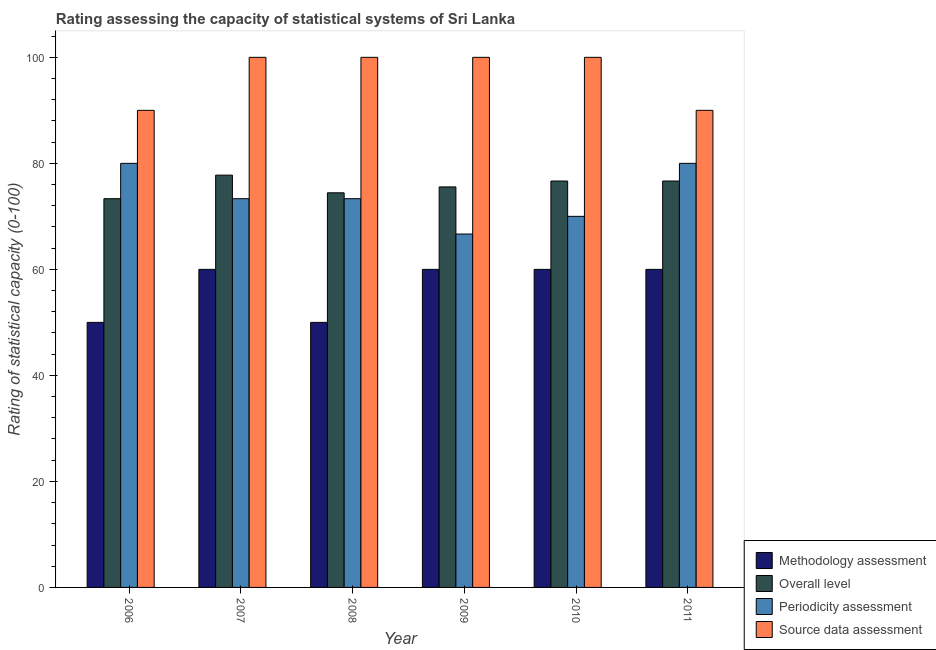How many different coloured bars are there?
Give a very brief answer. 4. Are the number of bars on each tick of the X-axis equal?
Provide a short and direct response. Yes. How many bars are there on the 3rd tick from the left?
Keep it short and to the point. 4. How many bars are there on the 5th tick from the right?
Your response must be concise. 4. What is the label of the 2nd group of bars from the left?
Make the answer very short. 2007. What is the methodology assessment rating in 2010?
Your answer should be compact. 60. Across all years, what is the maximum source data assessment rating?
Provide a succinct answer. 100. Across all years, what is the minimum source data assessment rating?
Give a very brief answer. 90. In which year was the methodology assessment rating minimum?
Your answer should be very brief. 2006. What is the total source data assessment rating in the graph?
Provide a succinct answer. 580. What is the difference between the overall level rating in 2008 and that in 2009?
Provide a short and direct response. -1.11. What is the difference between the methodology assessment rating in 2008 and the overall level rating in 2009?
Offer a very short reply. -10. What is the average methodology assessment rating per year?
Provide a succinct answer. 56.67. In the year 2010, what is the difference between the source data assessment rating and methodology assessment rating?
Give a very brief answer. 0. What is the ratio of the methodology assessment rating in 2006 to that in 2007?
Offer a very short reply. 0.83. What is the difference between the highest and the second highest source data assessment rating?
Give a very brief answer. 0. What is the difference between the highest and the lowest source data assessment rating?
Your answer should be compact. 10. Is the sum of the overall level rating in 2009 and 2010 greater than the maximum source data assessment rating across all years?
Give a very brief answer. Yes. Is it the case that in every year, the sum of the source data assessment rating and methodology assessment rating is greater than the sum of periodicity assessment rating and overall level rating?
Offer a terse response. Yes. What does the 4th bar from the left in 2006 represents?
Keep it short and to the point. Source data assessment. What does the 1st bar from the right in 2006 represents?
Your answer should be very brief. Source data assessment. How many bars are there?
Ensure brevity in your answer.  24. Are the values on the major ticks of Y-axis written in scientific E-notation?
Your response must be concise. No. Does the graph contain any zero values?
Provide a succinct answer. No. Does the graph contain grids?
Your answer should be compact. No. How many legend labels are there?
Your answer should be compact. 4. How are the legend labels stacked?
Your answer should be very brief. Vertical. What is the title of the graph?
Make the answer very short. Rating assessing the capacity of statistical systems of Sri Lanka. Does "Fiscal policy" appear as one of the legend labels in the graph?
Your answer should be compact. No. What is the label or title of the X-axis?
Make the answer very short. Year. What is the label or title of the Y-axis?
Provide a short and direct response. Rating of statistical capacity (0-100). What is the Rating of statistical capacity (0-100) in Methodology assessment in 2006?
Offer a terse response. 50. What is the Rating of statistical capacity (0-100) in Overall level in 2006?
Offer a very short reply. 73.33. What is the Rating of statistical capacity (0-100) in Periodicity assessment in 2006?
Make the answer very short. 80. What is the Rating of statistical capacity (0-100) of Methodology assessment in 2007?
Your answer should be very brief. 60. What is the Rating of statistical capacity (0-100) of Overall level in 2007?
Provide a short and direct response. 77.78. What is the Rating of statistical capacity (0-100) of Periodicity assessment in 2007?
Make the answer very short. 73.33. What is the Rating of statistical capacity (0-100) in Overall level in 2008?
Provide a short and direct response. 74.44. What is the Rating of statistical capacity (0-100) in Periodicity assessment in 2008?
Keep it short and to the point. 73.33. What is the Rating of statistical capacity (0-100) of Source data assessment in 2008?
Keep it short and to the point. 100. What is the Rating of statistical capacity (0-100) in Methodology assessment in 2009?
Ensure brevity in your answer.  60. What is the Rating of statistical capacity (0-100) of Overall level in 2009?
Provide a succinct answer. 75.56. What is the Rating of statistical capacity (0-100) in Periodicity assessment in 2009?
Make the answer very short. 66.67. What is the Rating of statistical capacity (0-100) of Overall level in 2010?
Your answer should be compact. 76.67. What is the Rating of statistical capacity (0-100) in Periodicity assessment in 2010?
Keep it short and to the point. 70. What is the Rating of statistical capacity (0-100) in Source data assessment in 2010?
Provide a succinct answer. 100. What is the Rating of statistical capacity (0-100) of Overall level in 2011?
Provide a succinct answer. 76.67. What is the Rating of statistical capacity (0-100) of Periodicity assessment in 2011?
Your response must be concise. 80. Across all years, what is the maximum Rating of statistical capacity (0-100) of Methodology assessment?
Ensure brevity in your answer.  60. Across all years, what is the maximum Rating of statistical capacity (0-100) in Overall level?
Keep it short and to the point. 77.78. Across all years, what is the maximum Rating of statistical capacity (0-100) of Periodicity assessment?
Give a very brief answer. 80. Across all years, what is the minimum Rating of statistical capacity (0-100) in Methodology assessment?
Provide a short and direct response. 50. Across all years, what is the minimum Rating of statistical capacity (0-100) of Overall level?
Provide a succinct answer. 73.33. Across all years, what is the minimum Rating of statistical capacity (0-100) in Periodicity assessment?
Provide a short and direct response. 66.67. Across all years, what is the minimum Rating of statistical capacity (0-100) in Source data assessment?
Your answer should be very brief. 90. What is the total Rating of statistical capacity (0-100) of Methodology assessment in the graph?
Offer a very short reply. 340. What is the total Rating of statistical capacity (0-100) of Overall level in the graph?
Your response must be concise. 454.44. What is the total Rating of statistical capacity (0-100) in Periodicity assessment in the graph?
Your response must be concise. 443.33. What is the total Rating of statistical capacity (0-100) in Source data assessment in the graph?
Your response must be concise. 580. What is the difference between the Rating of statistical capacity (0-100) in Methodology assessment in 2006 and that in 2007?
Give a very brief answer. -10. What is the difference between the Rating of statistical capacity (0-100) in Overall level in 2006 and that in 2007?
Keep it short and to the point. -4.44. What is the difference between the Rating of statistical capacity (0-100) in Overall level in 2006 and that in 2008?
Offer a terse response. -1.11. What is the difference between the Rating of statistical capacity (0-100) of Periodicity assessment in 2006 and that in 2008?
Ensure brevity in your answer.  6.67. What is the difference between the Rating of statistical capacity (0-100) of Source data assessment in 2006 and that in 2008?
Your response must be concise. -10. What is the difference between the Rating of statistical capacity (0-100) in Methodology assessment in 2006 and that in 2009?
Keep it short and to the point. -10. What is the difference between the Rating of statistical capacity (0-100) of Overall level in 2006 and that in 2009?
Your answer should be very brief. -2.22. What is the difference between the Rating of statistical capacity (0-100) of Periodicity assessment in 2006 and that in 2009?
Ensure brevity in your answer.  13.33. What is the difference between the Rating of statistical capacity (0-100) in Source data assessment in 2006 and that in 2009?
Provide a succinct answer. -10. What is the difference between the Rating of statistical capacity (0-100) in Overall level in 2006 and that in 2010?
Provide a short and direct response. -3.33. What is the difference between the Rating of statistical capacity (0-100) of Source data assessment in 2006 and that in 2010?
Ensure brevity in your answer.  -10. What is the difference between the Rating of statistical capacity (0-100) in Methodology assessment in 2006 and that in 2011?
Give a very brief answer. -10. What is the difference between the Rating of statistical capacity (0-100) in Overall level in 2006 and that in 2011?
Give a very brief answer. -3.33. What is the difference between the Rating of statistical capacity (0-100) of Methodology assessment in 2007 and that in 2008?
Offer a terse response. 10. What is the difference between the Rating of statistical capacity (0-100) of Overall level in 2007 and that in 2008?
Your answer should be very brief. 3.33. What is the difference between the Rating of statistical capacity (0-100) of Periodicity assessment in 2007 and that in 2008?
Your response must be concise. 0. What is the difference between the Rating of statistical capacity (0-100) in Source data assessment in 2007 and that in 2008?
Provide a short and direct response. 0. What is the difference between the Rating of statistical capacity (0-100) in Methodology assessment in 2007 and that in 2009?
Offer a very short reply. 0. What is the difference between the Rating of statistical capacity (0-100) of Overall level in 2007 and that in 2009?
Ensure brevity in your answer.  2.22. What is the difference between the Rating of statistical capacity (0-100) in Periodicity assessment in 2007 and that in 2009?
Provide a succinct answer. 6.67. What is the difference between the Rating of statistical capacity (0-100) in Overall level in 2007 and that in 2010?
Ensure brevity in your answer.  1.11. What is the difference between the Rating of statistical capacity (0-100) of Methodology assessment in 2007 and that in 2011?
Your answer should be compact. 0. What is the difference between the Rating of statistical capacity (0-100) in Periodicity assessment in 2007 and that in 2011?
Offer a very short reply. -6.67. What is the difference between the Rating of statistical capacity (0-100) in Source data assessment in 2007 and that in 2011?
Give a very brief answer. 10. What is the difference between the Rating of statistical capacity (0-100) in Methodology assessment in 2008 and that in 2009?
Offer a terse response. -10. What is the difference between the Rating of statistical capacity (0-100) of Overall level in 2008 and that in 2009?
Give a very brief answer. -1.11. What is the difference between the Rating of statistical capacity (0-100) in Source data assessment in 2008 and that in 2009?
Give a very brief answer. 0. What is the difference between the Rating of statistical capacity (0-100) of Methodology assessment in 2008 and that in 2010?
Provide a succinct answer. -10. What is the difference between the Rating of statistical capacity (0-100) in Overall level in 2008 and that in 2010?
Provide a succinct answer. -2.22. What is the difference between the Rating of statistical capacity (0-100) in Periodicity assessment in 2008 and that in 2010?
Ensure brevity in your answer.  3.33. What is the difference between the Rating of statistical capacity (0-100) in Overall level in 2008 and that in 2011?
Offer a terse response. -2.22. What is the difference between the Rating of statistical capacity (0-100) of Periodicity assessment in 2008 and that in 2011?
Provide a succinct answer. -6.67. What is the difference between the Rating of statistical capacity (0-100) of Source data assessment in 2008 and that in 2011?
Provide a succinct answer. 10. What is the difference between the Rating of statistical capacity (0-100) in Overall level in 2009 and that in 2010?
Give a very brief answer. -1.11. What is the difference between the Rating of statistical capacity (0-100) in Periodicity assessment in 2009 and that in 2010?
Keep it short and to the point. -3.33. What is the difference between the Rating of statistical capacity (0-100) of Methodology assessment in 2009 and that in 2011?
Your answer should be compact. 0. What is the difference between the Rating of statistical capacity (0-100) of Overall level in 2009 and that in 2011?
Ensure brevity in your answer.  -1.11. What is the difference between the Rating of statistical capacity (0-100) of Periodicity assessment in 2009 and that in 2011?
Provide a succinct answer. -13.33. What is the difference between the Rating of statistical capacity (0-100) in Source data assessment in 2009 and that in 2011?
Provide a succinct answer. 10. What is the difference between the Rating of statistical capacity (0-100) in Methodology assessment in 2010 and that in 2011?
Offer a very short reply. 0. What is the difference between the Rating of statistical capacity (0-100) in Source data assessment in 2010 and that in 2011?
Your answer should be compact. 10. What is the difference between the Rating of statistical capacity (0-100) in Methodology assessment in 2006 and the Rating of statistical capacity (0-100) in Overall level in 2007?
Your answer should be compact. -27.78. What is the difference between the Rating of statistical capacity (0-100) of Methodology assessment in 2006 and the Rating of statistical capacity (0-100) of Periodicity assessment in 2007?
Offer a very short reply. -23.33. What is the difference between the Rating of statistical capacity (0-100) of Methodology assessment in 2006 and the Rating of statistical capacity (0-100) of Source data assessment in 2007?
Provide a succinct answer. -50. What is the difference between the Rating of statistical capacity (0-100) in Overall level in 2006 and the Rating of statistical capacity (0-100) in Source data assessment in 2007?
Offer a terse response. -26.67. What is the difference between the Rating of statistical capacity (0-100) in Methodology assessment in 2006 and the Rating of statistical capacity (0-100) in Overall level in 2008?
Your response must be concise. -24.44. What is the difference between the Rating of statistical capacity (0-100) in Methodology assessment in 2006 and the Rating of statistical capacity (0-100) in Periodicity assessment in 2008?
Provide a short and direct response. -23.33. What is the difference between the Rating of statistical capacity (0-100) of Methodology assessment in 2006 and the Rating of statistical capacity (0-100) of Source data assessment in 2008?
Make the answer very short. -50. What is the difference between the Rating of statistical capacity (0-100) of Overall level in 2006 and the Rating of statistical capacity (0-100) of Periodicity assessment in 2008?
Give a very brief answer. 0. What is the difference between the Rating of statistical capacity (0-100) in Overall level in 2006 and the Rating of statistical capacity (0-100) in Source data assessment in 2008?
Your answer should be compact. -26.67. What is the difference between the Rating of statistical capacity (0-100) in Periodicity assessment in 2006 and the Rating of statistical capacity (0-100) in Source data assessment in 2008?
Give a very brief answer. -20. What is the difference between the Rating of statistical capacity (0-100) of Methodology assessment in 2006 and the Rating of statistical capacity (0-100) of Overall level in 2009?
Keep it short and to the point. -25.56. What is the difference between the Rating of statistical capacity (0-100) in Methodology assessment in 2006 and the Rating of statistical capacity (0-100) in Periodicity assessment in 2009?
Offer a terse response. -16.67. What is the difference between the Rating of statistical capacity (0-100) of Overall level in 2006 and the Rating of statistical capacity (0-100) of Periodicity assessment in 2009?
Your answer should be very brief. 6.67. What is the difference between the Rating of statistical capacity (0-100) in Overall level in 2006 and the Rating of statistical capacity (0-100) in Source data assessment in 2009?
Give a very brief answer. -26.67. What is the difference between the Rating of statistical capacity (0-100) of Periodicity assessment in 2006 and the Rating of statistical capacity (0-100) of Source data assessment in 2009?
Ensure brevity in your answer.  -20. What is the difference between the Rating of statistical capacity (0-100) in Methodology assessment in 2006 and the Rating of statistical capacity (0-100) in Overall level in 2010?
Provide a short and direct response. -26.67. What is the difference between the Rating of statistical capacity (0-100) of Methodology assessment in 2006 and the Rating of statistical capacity (0-100) of Periodicity assessment in 2010?
Make the answer very short. -20. What is the difference between the Rating of statistical capacity (0-100) in Overall level in 2006 and the Rating of statistical capacity (0-100) in Periodicity assessment in 2010?
Offer a terse response. 3.33. What is the difference between the Rating of statistical capacity (0-100) of Overall level in 2006 and the Rating of statistical capacity (0-100) of Source data assessment in 2010?
Your answer should be compact. -26.67. What is the difference between the Rating of statistical capacity (0-100) in Periodicity assessment in 2006 and the Rating of statistical capacity (0-100) in Source data assessment in 2010?
Ensure brevity in your answer.  -20. What is the difference between the Rating of statistical capacity (0-100) of Methodology assessment in 2006 and the Rating of statistical capacity (0-100) of Overall level in 2011?
Provide a succinct answer. -26.67. What is the difference between the Rating of statistical capacity (0-100) of Overall level in 2006 and the Rating of statistical capacity (0-100) of Periodicity assessment in 2011?
Offer a terse response. -6.67. What is the difference between the Rating of statistical capacity (0-100) of Overall level in 2006 and the Rating of statistical capacity (0-100) of Source data assessment in 2011?
Provide a short and direct response. -16.67. What is the difference between the Rating of statistical capacity (0-100) of Methodology assessment in 2007 and the Rating of statistical capacity (0-100) of Overall level in 2008?
Offer a very short reply. -14.44. What is the difference between the Rating of statistical capacity (0-100) in Methodology assessment in 2007 and the Rating of statistical capacity (0-100) in Periodicity assessment in 2008?
Ensure brevity in your answer.  -13.33. What is the difference between the Rating of statistical capacity (0-100) of Overall level in 2007 and the Rating of statistical capacity (0-100) of Periodicity assessment in 2008?
Offer a terse response. 4.44. What is the difference between the Rating of statistical capacity (0-100) in Overall level in 2007 and the Rating of statistical capacity (0-100) in Source data assessment in 2008?
Provide a short and direct response. -22.22. What is the difference between the Rating of statistical capacity (0-100) of Periodicity assessment in 2007 and the Rating of statistical capacity (0-100) of Source data assessment in 2008?
Make the answer very short. -26.67. What is the difference between the Rating of statistical capacity (0-100) of Methodology assessment in 2007 and the Rating of statistical capacity (0-100) of Overall level in 2009?
Keep it short and to the point. -15.56. What is the difference between the Rating of statistical capacity (0-100) of Methodology assessment in 2007 and the Rating of statistical capacity (0-100) of Periodicity assessment in 2009?
Keep it short and to the point. -6.67. What is the difference between the Rating of statistical capacity (0-100) in Methodology assessment in 2007 and the Rating of statistical capacity (0-100) in Source data assessment in 2009?
Offer a terse response. -40. What is the difference between the Rating of statistical capacity (0-100) in Overall level in 2007 and the Rating of statistical capacity (0-100) in Periodicity assessment in 2009?
Ensure brevity in your answer.  11.11. What is the difference between the Rating of statistical capacity (0-100) in Overall level in 2007 and the Rating of statistical capacity (0-100) in Source data assessment in 2009?
Give a very brief answer. -22.22. What is the difference between the Rating of statistical capacity (0-100) in Periodicity assessment in 2007 and the Rating of statistical capacity (0-100) in Source data assessment in 2009?
Make the answer very short. -26.67. What is the difference between the Rating of statistical capacity (0-100) in Methodology assessment in 2007 and the Rating of statistical capacity (0-100) in Overall level in 2010?
Offer a terse response. -16.67. What is the difference between the Rating of statistical capacity (0-100) of Methodology assessment in 2007 and the Rating of statistical capacity (0-100) of Source data assessment in 2010?
Your answer should be very brief. -40. What is the difference between the Rating of statistical capacity (0-100) in Overall level in 2007 and the Rating of statistical capacity (0-100) in Periodicity assessment in 2010?
Your answer should be compact. 7.78. What is the difference between the Rating of statistical capacity (0-100) of Overall level in 2007 and the Rating of statistical capacity (0-100) of Source data assessment in 2010?
Make the answer very short. -22.22. What is the difference between the Rating of statistical capacity (0-100) of Periodicity assessment in 2007 and the Rating of statistical capacity (0-100) of Source data assessment in 2010?
Your answer should be compact. -26.67. What is the difference between the Rating of statistical capacity (0-100) in Methodology assessment in 2007 and the Rating of statistical capacity (0-100) in Overall level in 2011?
Your answer should be very brief. -16.67. What is the difference between the Rating of statistical capacity (0-100) of Methodology assessment in 2007 and the Rating of statistical capacity (0-100) of Source data assessment in 2011?
Your answer should be very brief. -30. What is the difference between the Rating of statistical capacity (0-100) of Overall level in 2007 and the Rating of statistical capacity (0-100) of Periodicity assessment in 2011?
Offer a very short reply. -2.22. What is the difference between the Rating of statistical capacity (0-100) of Overall level in 2007 and the Rating of statistical capacity (0-100) of Source data assessment in 2011?
Keep it short and to the point. -12.22. What is the difference between the Rating of statistical capacity (0-100) in Periodicity assessment in 2007 and the Rating of statistical capacity (0-100) in Source data assessment in 2011?
Your answer should be compact. -16.67. What is the difference between the Rating of statistical capacity (0-100) in Methodology assessment in 2008 and the Rating of statistical capacity (0-100) in Overall level in 2009?
Give a very brief answer. -25.56. What is the difference between the Rating of statistical capacity (0-100) of Methodology assessment in 2008 and the Rating of statistical capacity (0-100) of Periodicity assessment in 2009?
Provide a succinct answer. -16.67. What is the difference between the Rating of statistical capacity (0-100) in Overall level in 2008 and the Rating of statistical capacity (0-100) in Periodicity assessment in 2009?
Make the answer very short. 7.78. What is the difference between the Rating of statistical capacity (0-100) in Overall level in 2008 and the Rating of statistical capacity (0-100) in Source data assessment in 2009?
Your answer should be compact. -25.56. What is the difference between the Rating of statistical capacity (0-100) in Periodicity assessment in 2008 and the Rating of statistical capacity (0-100) in Source data assessment in 2009?
Offer a very short reply. -26.67. What is the difference between the Rating of statistical capacity (0-100) in Methodology assessment in 2008 and the Rating of statistical capacity (0-100) in Overall level in 2010?
Your answer should be very brief. -26.67. What is the difference between the Rating of statistical capacity (0-100) of Methodology assessment in 2008 and the Rating of statistical capacity (0-100) of Periodicity assessment in 2010?
Ensure brevity in your answer.  -20. What is the difference between the Rating of statistical capacity (0-100) of Overall level in 2008 and the Rating of statistical capacity (0-100) of Periodicity assessment in 2010?
Your answer should be compact. 4.44. What is the difference between the Rating of statistical capacity (0-100) of Overall level in 2008 and the Rating of statistical capacity (0-100) of Source data assessment in 2010?
Offer a very short reply. -25.56. What is the difference between the Rating of statistical capacity (0-100) in Periodicity assessment in 2008 and the Rating of statistical capacity (0-100) in Source data assessment in 2010?
Offer a very short reply. -26.67. What is the difference between the Rating of statistical capacity (0-100) of Methodology assessment in 2008 and the Rating of statistical capacity (0-100) of Overall level in 2011?
Give a very brief answer. -26.67. What is the difference between the Rating of statistical capacity (0-100) of Methodology assessment in 2008 and the Rating of statistical capacity (0-100) of Source data assessment in 2011?
Give a very brief answer. -40. What is the difference between the Rating of statistical capacity (0-100) in Overall level in 2008 and the Rating of statistical capacity (0-100) in Periodicity assessment in 2011?
Your answer should be compact. -5.56. What is the difference between the Rating of statistical capacity (0-100) in Overall level in 2008 and the Rating of statistical capacity (0-100) in Source data assessment in 2011?
Keep it short and to the point. -15.56. What is the difference between the Rating of statistical capacity (0-100) in Periodicity assessment in 2008 and the Rating of statistical capacity (0-100) in Source data assessment in 2011?
Offer a very short reply. -16.67. What is the difference between the Rating of statistical capacity (0-100) in Methodology assessment in 2009 and the Rating of statistical capacity (0-100) in Overall level in 2010?
Make the answer very short. -16.67. What is the difference between the Rating of statistical capacity (0-100) in Methodology assessment in 2009 and the Rating of statistical capacity (0-100) in Periodicity assessment in 2010?
Your answer should be compact. -10. What is the difference between the Rating of statistical capacity (0-100) of Methodology assessment in 2009 and the Rating of statistical capacity (0-100) of Source data assessment in 2010?
Offer a very short reply. -40. What is the difference between the Rating of statistical capacity (0-100) of Overall level in 2009 and the Rating of statistical capacity (0-100) of Periodicity assessment in 2010?
Your answer should be compact. 5.56. What is the difference between the Rating of statistical capacity (0-100) in Overall level in 2009 and the Rating of statistical capacity (0-100) in Source data assessment in 2010?
Make the answer very short. -24.44. What is the difference between the Rating of statistical capacity (0-100) of Periodicity assessment in 2009 and the Rating of statistical capacity (0-100) of Source data assessment in 2010?
Ensure brevity in your answer.  -33.33. What is the difference between the Rating of statistical capacity (0-100) of Methodology assessment in 2009 and the Rating of statistical capacity (0-100) of Overall level in 2011?
Give a very brief answer. -16.67. What is the difference between the Rating of statistical capacity (0-100) in Methodology assessment in 2009 and the Rating of statistical capacity (0-100) in Source data assessment in 2011?
Provide a short and direct response. -30. What is the difference between the Rating of statistical capacity (0-100) of Overall level in 2009 and the Rating of statistical capacity (0-100) of Periodicity assessment in 2011?
Keep it short and to the point. -4.44. What is the difference between the Rating of statistical capacity (0-100) of Overall level in 2009 and the Rating of statistical capacity (0-100) of Source data assessment in 2011?
Offer a terse response. -14.44. What is the difference between the Rating of statistical capacity (0-100) in Periodicity assessment in 2009 and the Rating of statistical capacity (0-100) in Source data assessment in 2011?
Your answer should be very brief. -23.33. What is the difference between the Rating of statistical capacity (0-100) in Methodology assessment in 2010 and the Rating of statistical capacity (0-100) in Overall level in 2011?
Provide a succinct answer. -16.67. What is the difference between the Rating of statistical capacity (0-100) of Methodology assessment in 2010 and the Rating of statistical capacity (0-100) of Source data assessment in 2011?
Your answer should be compact. -30. What is the difference between the Rating of statistical capacity (0-100) in Overall level in 2010 and the Rating of statistical capacity (0-100) in Source data assessment in 2011?
Your answer should be compact. -13.33. What is the average Rating of statistical capacity (0-100) in Methodology assessment per year?
Offer a very short reply. 56.67. What is the average Rating of statistical capacity (0-100) in Overall level per year?
Make the answer very short. 75.74. What is the average Rating of statistical capacity (0-100) of Periodicity assessment per year?
Offer a very short reply. 73.89. What is the average Rating of statistical capacity (0-100) in Source data assessment per year?
Provide a short and direct response. 96.67. In the year 2006, what is the difference between the Rating of statistical capacity (0-100) of Methodology assessment and Rating of statistical capacity (0-100) of Overall level?
Provide a short and direct response. -23.33. In the year 2006, what is the difference between the Rating of statistical capacity (0-100) of Methodology assessment and Rating of statistical capacity (0-100) of Source data assessment?
Your answer should be compact. -40. In the year 2006, what is the difference between the Rating of statistical capacity (0-100) in Overall level and Rating of statistical capacity (0-100) in Periodicity assessment?
Your answer should be compact. -6.67. In the year 2006, what is the difference between the Rating of statistical capacity (0-100) in Overall level and Rating of statistical capacity (0-100) in Source data assessment?
Provide a short and direct response. -16.67. In the year 2006, what is the difference between the Rating of statistical capacity (0-100) in Periodicity assessment and Rating of statistical capacity (0-100) in Source data assessment?
Your response must be concise. -10. In the year 2007, what is the difference between the Rating of statistical capacity (0-100) of Methodology assessment and Rating of statistical capacity (0-100) of Overall level?
Your answer should be very brief. -17.78. In the year 2007, what is the difference between the Rating of statistical capacity (0-100) of Methodology assessment and Rating of statistical capacity (0-100) of Periodicity assessment?
Ensure brevity in your answer.  -13.33. In the year 2007, what is the difference between the Rating of statistical capacity (0-100) of Overall level and Rating of statistical capacity (0-100) of Periodicity assessment?
Provide a succinct answer. 4.44. In the year 2007, what is the difference between the Rating of statistical capacity (0-100) of Overall level and Rating of statistical capacity (0-100) of Source data assessment?
Make the answer very short. -22.22. In the year 2007, what is the difference between the Rating of statistical capacity (0-100) of Periodicity assessment and Rating of statistical capacity (0-100) of Source data assessment?
Offer a terse response. -26.67. In the year 2008, what is the difference between the Rating of statistical capacity (0-100) in Methodology assessment and Rating of statistical capacity (0-100) in Overall level?
Offer a very short reply. -24.44. In the year 2008, what is the difference between the Rating of statistical capacity (0-100) in Methodology assessment and Rating of statistical capacity (0-100) in Periodicity assessment?
Ensure brevity in your answer.  -23.33. In the year 2008, what is the difference between the Rating of statistical capacity (0-100) of Overall level and Rating of statistical capacity (0-100) of Source data assessment?
Offer a terse response. -25.56. In the year 2008, what is the difference between the Rating of statistical capacity (0-100) in Periodicity assessment and Rating of statistical capacity (0-100) in Source data assessment?
Give a very brief answer. -26.67. In the year 2009, what is the difference between the Rating of statistical capacity (0-100) in Methodology assessment and Rating of statistical capacity (0-100) in Overall level?
Offer a terse response. -15.56. In the year 2009, what is the difference between the Rating of statistical capacity (0-100) of Methodology assessment and Rating of statistical capacity (0-100) of Periodicity assessment?
Give a very brief answer. -6.67. In the year 2009, what is the difference between the Rating of statistical capacity (0-100) in Methodology assessment and Rating of statistical capacity (0-100) in Source data assessment?
Your response must be concise. -40. In the year 2009, what is the difference between the Rating of statistical capacity (0-100) in Overall level and Rating of statistical capacity (0-100) in Periodicity assessment?
Ensure brevity in your answer.  8.89. In the year 2009, what is the difference between the Rating of statistical capacity (0-100) in Overall level and Rating of statistical capacity (0-100) in Source data assessment?
Provide a short and direct response. -24.44. In the year 2009, what is the difference between the Rating of statistical capacity (0-100) of Periodicity assessment and Rating of statistical capacity (0-100) of Source data assessment?
Provide a succinct answer. -33.33. In the year 2010, what is the difference between the Rating of statistical capacity (0-100) in Methodology assessment and Rating of statistical capacity (0-100) in Overall level?
Provide a succinct answer. -16.67. In the year 2010, what is the difference between the Rating of statistical capacity (0-100) in Methodology assessment and Rating of statistical capacity (0-100) in Source data assessment?
Make the answer very short. -40. In the year 2010, what is the difference between the Rating of statistical capacity (0-100) of Overall level and Rating of statistical capacity (0-100) of Periodicity assessment?
Keep it short and to the point. 6.67. In the year 2010, what is the difference between the Rating of statistical capacity (0-100) in Overall level and Rating of statistical capacity (0-100) in Source data assessment?
Make the answer very short. -23.33. In the year 2010, what is the difference between the Rating of statistical capacity (0-100) of Periodicity assessment and Rating of statistical capacity (0-100) of Source data assessment?
Your answer should be very brief. -30. In the year 2011, what is the difference between the Rating of statistical capacity (0-100) of Methodology assessment and Rating of statistical capacity (0-100) of Overall level?
Your answer should be compact. -16.67. In the year 2011, what is the difference between the Rating of statistical capacity (0-100) in Methodology assessment and Rating of statistical capacity (0-100) in Periodicity assessment?
Make the answer very short. -20. In the year 2011, what is the difference between the Rating of statistical capacity (0-100) in Methodology assessment and Rating of statistical capacity (0-100) in Source data assessment?
Provide a short and direct response. -30. In the year 2011, what is the difference between the Rating of statistical capacity (0-100) of Overall level and Rating of statistical capacity (0-100) of Periodicity assessment?
Your answer should be compact. -3.33. In the year 2011, what is the difference between the Rating of statistical capacity (0-100) in Overall level and Rating of statistical capacity (0-100) in Source data assessment?
Make the answer very short. -13.33. In the year 2011, what is the difference between the Rating of statistical capacity (0-100) in Periodicity assessment and Rating of statistical capacity (0-100) in Source data assessment?
Provide a succinct answer. -10. What is the ratio of the Rating of statistical capacity (0-100) in Overall level in 2006 to that in 2007?
Your answer should be compact. 0.94. What is the ratio of the Rating of statistical capacity (0-100) of Periodicity assessment in 2006 to that in 2007?
Ensure brevity in your answer.  1.09. What is the ratio of the Rating of statistical capacity (0-100) of Overall level in 2006 to that in 2008?
Your answer should be compact. 0.99. What is the ratio of the Rating of statistical capacity (0-100) of Source data assessment in 2006 to that in 2008?
Your answer should be compact. 0.9. What is the ratio of the Rating of statistical capacity (0-100) of Methodology assessment in 2006 to that in 2009?
Your response must be concise. 0.83. What is the ratio of the Rating of statistical capacity (0-100) of Overall level in 2006 to that in 2009?
Ensure brevity in your answer.  0.97. What is the ratio of the Rating of statistical capacity (0-100) in Overall level in 2006 to that in 2010?
Give a very brief answer. 0.96. What is the ratio of the Rating of statistical capacity (0-100) of Periodicity assessment in 2006 to that in 2010?
Your answer should be compact. 1.14. What is the ratio of the Rating of statistical capacity (0-100) in Overall level in 2006 to that in 2011?
Give a very brief answer. 0.96. What is the ratio of the Rating of statistical capacity (0-100) in Methodology assessment in 2007 to that in 2008?
Your answer should be compact. 1.2. What is the ratio of the Rating of statistical capacity (0-100) of Overall level in 2007 to that in 2008?
Your answer should be very brief. 1.04. What is the ratio of the Rating of statistical capacity (0-100) of Periodicity assessment in 2007 to that in 2008?
Make the answer very short. 1. What is the ratio of the Rating of statistical capacity (0-100) in Methodology assessment in 2007 to that in 2009?
Your answer should be very brief. 1. What is the ratio of the Rating of statistical capacity (0-100) in Overall level in 2007 to that in 2009?
Your answer should be compact. 1.03. What is the ratio of the Rating of statistical capacity (0-100) of Periodicity assessment in 2007 to that in 2009?
Offer a terse response. 1.1. What is the ratio of the Rating of statistical capacity (0-100) of Methodology assessment in 2007 to that in 2010?
Your answer should be compact. 1. What is the ratio of the Rating of statistical capacity (0-100) in Overall level in 2007 to that in 2010?
Your response must be concise. 1.01. What is the ratio of the Rating of statistical capacity (0-100) in Periodicity assessment in 2007 to that in 2010?
Give a very brief answer. 1.05. What is the ratio of the Rating of statistical capacity (0-100) of Methodology assessment in 2007 to that in 2011?
Your response must be concise. 1. What is the ratio of the Rating of statistical capacity (0-100) of Overall level in 2007 to that in 2011?
Offer a very short reply. 1.01. What is the ratio of the Rating of statistical capacity (0-100) in Methodology assessment in 2008 to that in 2009?
Your response must be concise. 0.83. What is the ratio of the Rating of statistical capacity (0-100) of Periodicity assessment in 2008 to that in 2009?
Provide a short and direct response. 1.1. What is the ratio of the Rating of statistical capacity (0-100) in Source data assessment in 2008 to that in 2009?
Provide a succinct answer. 1. What is the ratio of the Rating of statistical capacity (0-100) of Overall level in 2008 to that in 2010?
Give a very brief answer. 0.97. What is the ratio of the Rating of statistical capacity (0-100) of Periodicity assessment in 2008 to that in 2010?
Offer a terse response. 1.05. What is the ratio of the Rating of statistical capacity (0-100) of Source data assessment in 2008 to that in 2010?
Provide a short and direct response. 1. What is the ratio of the Rating of statistical capacity (0-100) of Methodology assessment in 2008 to that in 2011?
Keep it short and to the point. 0.83. What is the ratio of the Rating of statistical capacity (0-100) in Overall level in 2008 to that in 2011?
Provide a succinct answer. 0.97. What is the ratio of the Rating of statistical capacity (0-100) of Source data assessment in 2008 to that in 2011?
Your response must be concise. 1.11. What is the ratio of the Rating of statistical capacity (0-100) in Methodology assessment in 2009 to that in 2010?
Ensure brevity in your answer.  1. What is the ratio of the Rating of statistical capacity (0-100) of Overall level in 2009 to that in 2010?
Keep it short and to the point. 0.99. What is the ratio of the Rating of statistical capacity (0-100) of Overall level in 2009 to that in 2011?
Your response must be concise. 0.99. What is the ratio of the Rating of statistical capacity (0-100) of Source data assessment in 2009 to that in 2011?
Ensure brevity in your answer.  1.11. What is the ratio of the Rating of statistical capacity (0-100) in Source data assessment in 2010 to that in 2011?
Offer a very short reply. 1.11. What is the difference between the highest and the second highest Rating of statistical capacity (0-100) in Methodology assessment?
Your answer should be very brief. 0. What is the difference between the highest and the second highest Rating of statistical capacity (0-100) in Overall level?
Make the answer very short. 1.11. What is the difference between the highest and the second highest Rating of statistical capacity (0-100) of Periodicity assessment?
Keep it short and to the point. 0. What is the difference between the highest and the lowest Rating of statistical capacity (0-100) of Overall level?
Provide a succinct answer. 4.44. What is the difference between the highest and the lowest Rating of statistical capacity (0-100) in Periodicity assessment?
Provide a succinct answer. 13.33. What is the difference between the highest and the lowest Rating of statistical capacity (0-100) in Source data assessment?
Keep it short and to the point. 10. 